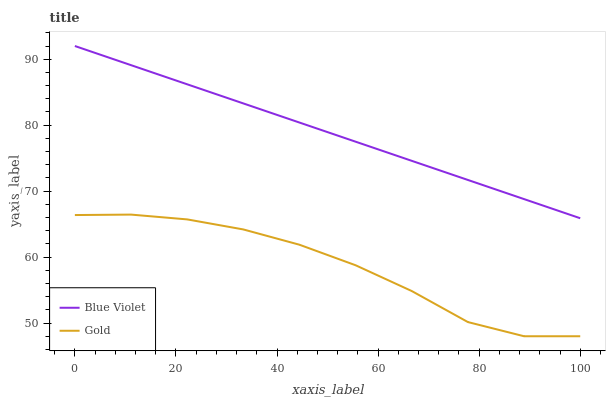Does Gold have the minimum area under the curve?
Answer yes or no. Yes. Does Blue Violet have the maximum area under the curve?
Answer yes or no. Yes. Does Blue Violet have the minimum area under the curve?
Answer yes or no. No. Is Blue Violet the smoothest?
Answer yes or no. Yes. Is Gold the roughest?
Answer yes or no. Yes. Is Blue Violet the roughest?
Answer yes or no. No. Does Blue Violet have the lowest value?
Answer yes or no. No. Does Blue Violet have the highest value?
Answer yes or no. Yes. Is Gold less than Blue Violet?
Answer yes or no. Yes. Is Blue Violet greater than Gold?
Answer yes or no. Yes. Does Gold intersect Blue Violet?
Answer yes or no. No. 